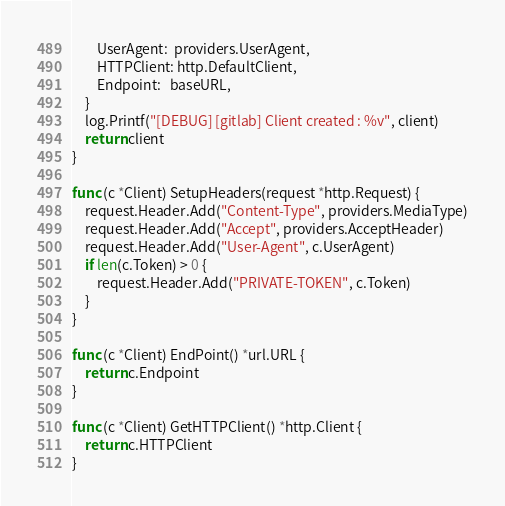Convert code to text. <code><loc_0><loc_0><loc_500><loc_500><_Go_>		UserAgent:  providers.UserAgent,
		HTTPClient: http.DefaultClient,
		Endpoint:   baseURL,
	}
	log.Printf("[DEBUG] [gitlab] Client created : %v", client)
	return client
}

func (c *Client) SetupHeaders(request *http.Request) {
	request.Header.Add("Content-Type", providers.MediaType)
	request.Header.Add("Accept", providers.AcceptHeader)
	request.Header.Add("User-Agent", c.UserAgent)
	if len(c.Token) > 0 {
		request.Header.Add("PRIVATE-TOKEN", c.Token)
	}
}

func (c *Client) EndPoint() *url.URL {
	return c.Endpoint
}

func (c *Client) GetHTTPClient() *http.Client {
	return c.HTTPClient
}
</code> 